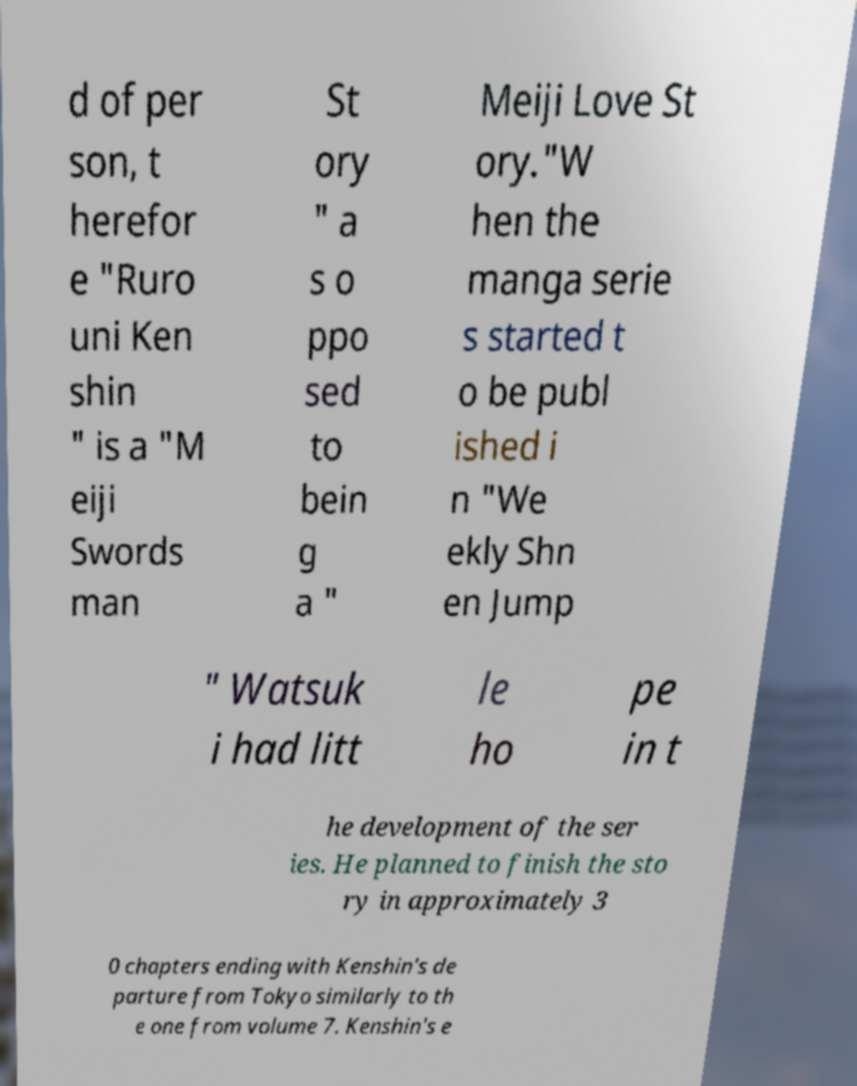What messages or text are displayed in this image? I need them in a readable, typed format. d of per son, t herefor e "Ruro uni Ken shin " is a "M eiji Swords man St ory " a s o ppo sed to bein g a " Meiji Love St ory."W hen the manga serie s started t o be publ ished i n "We ekly Shn en Jump " Watsuk i had litt le ho pe in t he development of the ser ies. He planned to finish the sto ry in approximately 3 0 chapters ending with Kenshin's de parture from Tokyo similarly to th e one from volume 7. Kenshin's e 